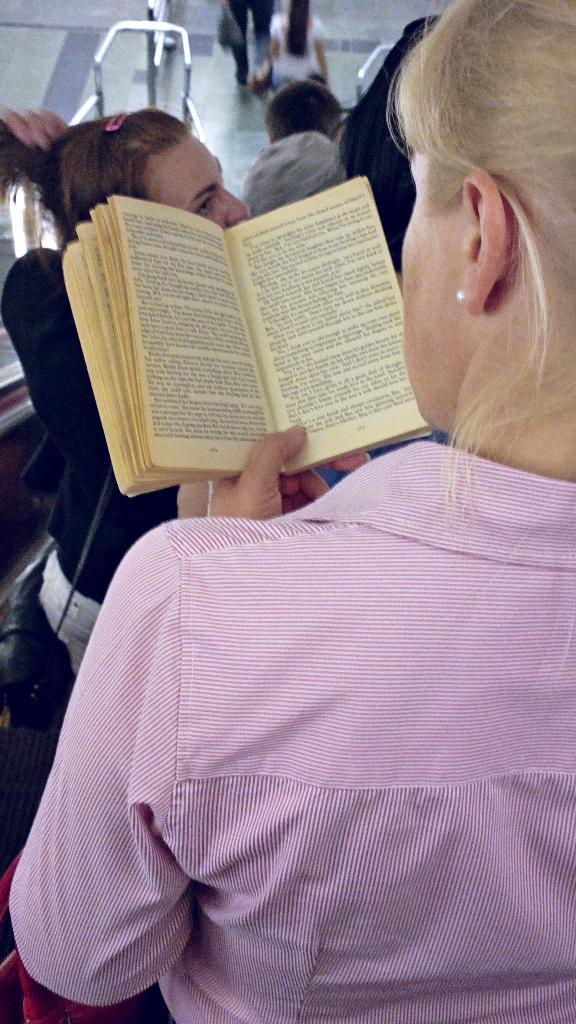Who is present in the image? There is a woman in the image, along with other people. What is the woman holding in the image? The woman is holding a book in the image. What type of surface is visible in the image? There is a floor visible in the image. What object can be seen in the image that might be used for carrying items? There is a bag in the image that can be used for carrying items. What are the rods in the image used for? The purpose of the rods in the image is not specified, but they could be used for various purposes such as support or decoration. What color is the crayon that the woman is using to draw in the image? There is no crayon present in the image; the woman is holding a book. What offer is being made by the people in the image? There is no offer being made in the image; the people are simply present along with the woman holding a book. 